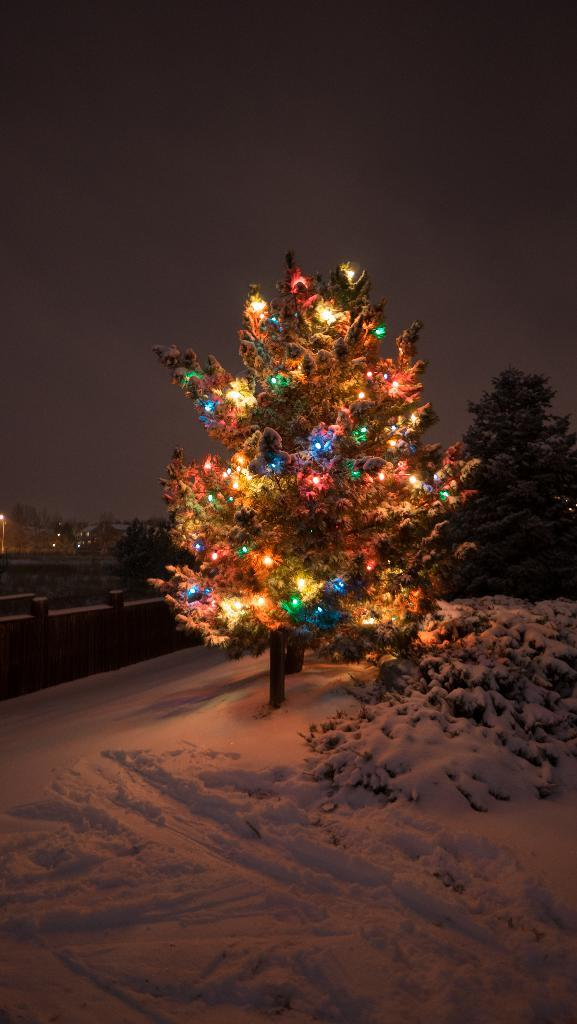What is the main feature of the tree in the image? The tree in the image has different colors of lights. What is the condition of the ground in the image? There is snow on the ground in the image. Can you describe the other tree in the image? There is another tree on the right side of the image. What can be seen in the background of the image? The sky is visible in the background of the image. How does the snail move across the snow in the image? There is no snail present in the image, so it cannot be determined how it would move across the snow. 